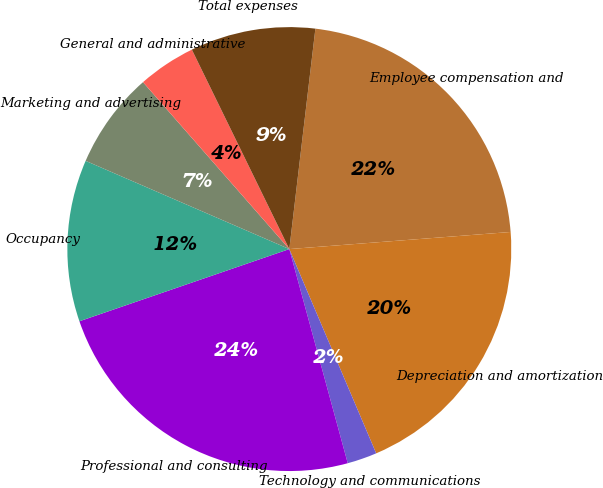Convert chart. <chart><loc_0><loc_0><loc_500><loc_500><pie_chart><fcel>Employee compensation and<fcel>Depreciation and amortization<fcel>Technology and communications<fcel>Professional and consulting<fcel>Occupancy<fcel>Marketing and advertising<fcel>General and administrative<fcel>Total expenses<nl><fcel>21.9%<fcel>19.83%<fcel>2.16%<fcel>23.97%<fcel>11.78%<fcel>7.04%<fcel>4.22%<fcel>9.11%<nl></chart> 